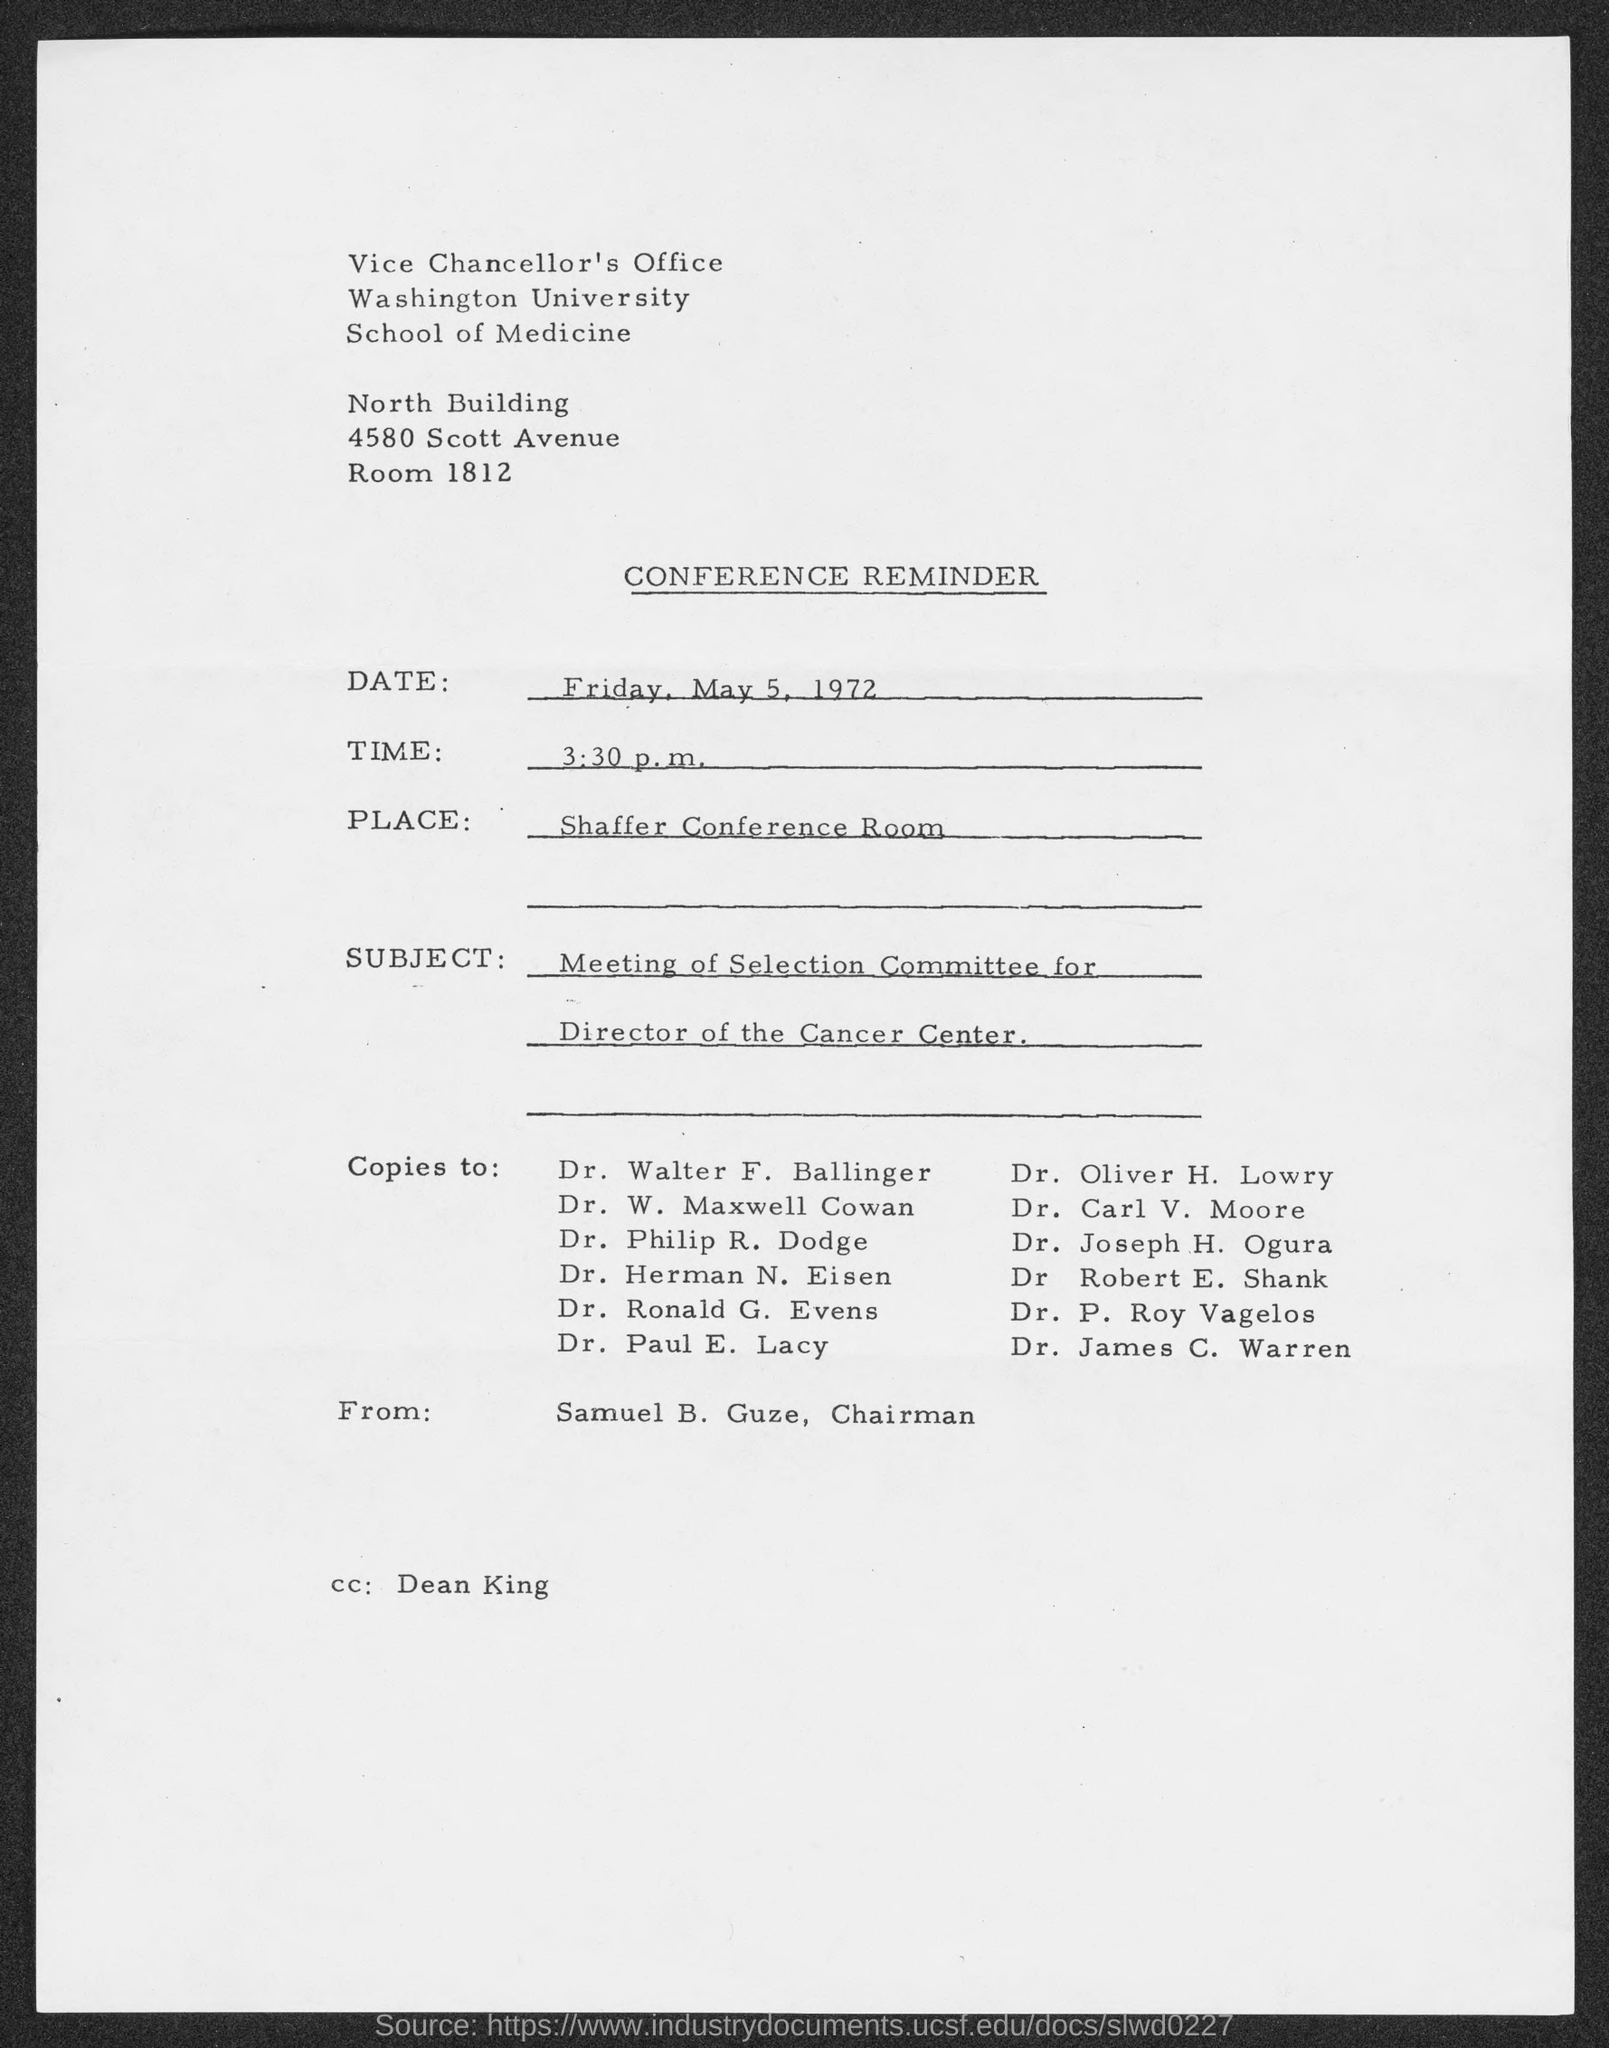Give some essential details in this illustration. The memorandum is from Samuel B. Guze. The person referred to in the email message is Dean King. This is a Conference Reminder document. 